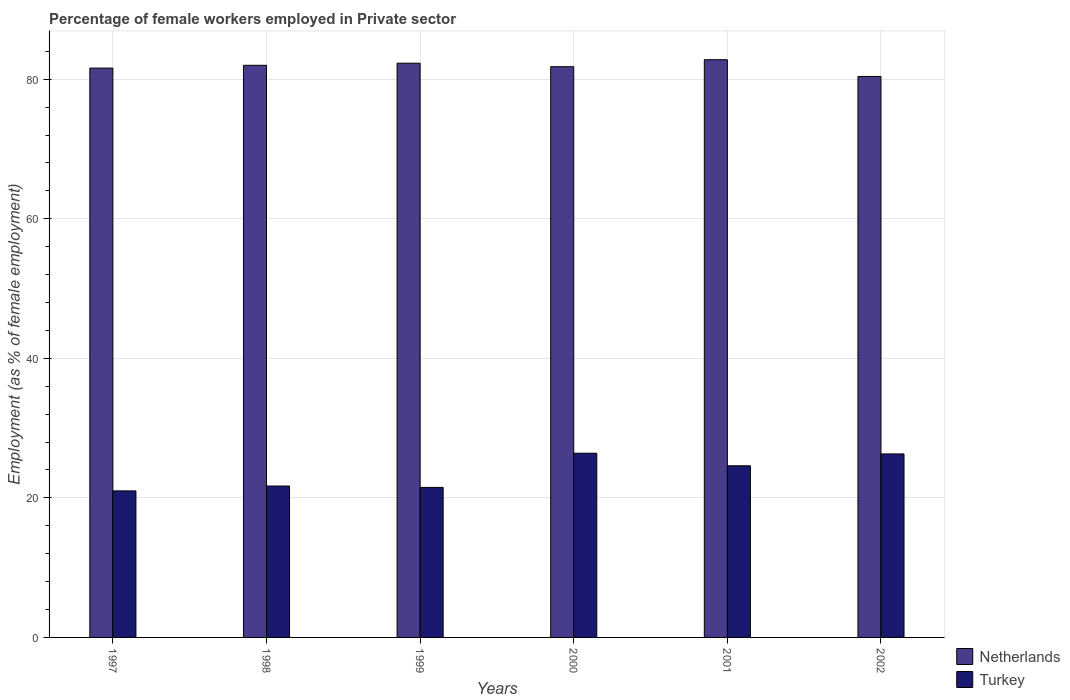Are the number of bars on each tick of the X-axis equal?
Keep it short and to the point. Yes. What is the label of the 3rd group of bars from the left?
Make the answer very short. 1999. Across all years, what is the maximum percentage of females employed in Private sector in Netherlands?
Give a very brief answer. 82.8. In which year was the percentage of females employed in Private sector in Netherlands maximum?
Provide a short and direct response. 2001. In which year was the percentage of females employed in Private sector in Netherlands minimum?
Your response must be concise. 2002. What is the total percentage of females employed in Private sector in Netherlands in the graph?
Keep it short and to the point. 490.9. What is the difference between the percentage of females employed in Private sector in Turkey in 1999 and that in 2000?
Provide a short and direct response. -4.9. What is the difference between the percentage of females employed in Private sector in Netherlands in 2002 and the percentage of females employed in Private sector in Turkey in 1999?
Ensure brevity in your answer.  58.9. What is the average percentage of females employed in Private sector in Netherlands per year?
Give a very brief answer. 81.82. In the year 2002, what is the difference between the percentage of females employed in Private sector in Netherlands and percentage of females employed in Private sector in Turkey?
Ensure brevity in your answer.  54.1. In how many years, is the percentage of females employed in Private sector in Turkey greater than 8 %?
Provide a succinct answer. 6. What is the ratio of the percentage of females employed in Private sector in Netherlands in 1997 to that in 1998?
Your response must be concise. 1. Is the difference between the percentage of females employed in Private sector in Netherlands in 1997 and 2001 greater than the difference between the percentage of females employed in Private sector in Turkey in 1997 and 2001?
Your answer should be compact. Yes. What is the difference between the highest and the second highest percentage of females employed in Private sector in Netherlands?
Provide a succinct answer. 0.5. What is the difference between the highest and the lowest percentage of females employed in Private sector in Turkey?
Keep it short and to the point. 5.4. What does the 2nd bar from the right in 1999 represents?
Offer a terse response. Netherlands. Are all the bars in the graph horizontal?
Keep it short and to the point. No. What is the difference between two consecutive major ticks on the Y-axis?
Make the answer very short. 20. Are the values on the major ticks of Y-axis written in scientific E-notation?
Make the answer very short. No. Does the graph contain any zero values?
Offer a terse response. No. Does the graph contain grids?
Offer a very short reply. Yes. How many legend labels are there?
Make the answer very short. 2. What is the title of the graph?
Offer a terse response. Percentage of female workers employed in Private sector. Does "Burundi" appear as one of the legend labels in the graph?
Offer a terse response. No. What is the label or title of the X-axis?
Your answer should be compact. Years. What is the label or title of the Y-axis?
Give a very brief answer. Employment (as % of female employment). What is the Employment (as % of female employment) of Netherlands in 1997?
Give a very brief answer. 81.6. What is the Employment (as % of female employment) of Turkey in 1998?
Your response must be concise. 21.7. What is the Employment (as % of female employment) of Netherlands in 1999?
Provide a succinct answer. 82.3. What is the Employment (as % of female employment) of Turkey in 1999?
Give a very brief answer. 21.5. What is the Employment (as % of female employment) in Netherlands in 2000?
Give a very brief answer. 81.8. What is the Employment (as % of female employment) of Turkey in 2000?
Your answer should be very brief. 26.4. What is the Employment (as % of female employment) of Netherlands in 2001?
Your answer should be compact. 82.8. What is the Employment (as % of female employment) of Turkey in 2001?
Give a very brief answer. 24.6. What is the Employment (as % of female employment) of Netherlands in 2002?
Offer a very short reply. 80.4. What is the Employment (as % of female employment) in Turkey in 2002?
Provide a short and direct response. 26.3. Across all years, what is the maximum Employment (as % of female employment) of Netherlands?
Your answer should be very brief. 82.8. Across all years, what is the maximum Employment (as % of female employment) of Turkey?
Provide a succinct answer. 26.4. Across all years, what is the minimum Employment (as % of female employment) of Netherlands?
Offer a very short reply. 80.4. Across all years, what is the minimum Employment (as % of female employment) of Turkey?
Provide a succinct answer. 21. What is the total Employment (as % of female employment) in Netherlands in the graph?
Make the answer very short. 490.9. What is the total Employment (as % of female employment) of Turkey in the graph?
Your answer should be very brief. 141.5. What is the difference between the Employment (as % of female employment) in Netherlands in 1997 and that in 1998?
Ensure brevity in your answer.  -0.4. What is the difference between the Employment (as % of female employment) of Turkey in 1997 and that in 1999?
Give a very brief answer. -0.5. What is the difference between the Employment (as % of female employment) of Netherlands in 1997 and that in 2000?
Your answer should be compact. -0.2. What is the difference between the Employment (as % of female employment) of Netherlands in 1997 and that in 2001?
Your response must be concise. -1.2. What is the difference between the Employment (as % of female employment) in Netherlands in 1997 and that in 2002?
Ensure brevity in your answer.  1.2. What is the difference between the Employment (as % of female employment) of Turkey in 1997 and that in 2002?
Your answer should be very brief. -5.3. What is the difference between the Employment (as % of female employment) of Turkey in 1998 and that in 1999?
Your response must be concise. 0.2. What is the difference between the Employment (as % of female employment) in Netherlands in 1998 and that in 2000?
Your answer should be compact. 0.2. What is the difference between the Employment (as % of female employment) in Turkey in 1998 and that in 2000?
Keep it short and to the point. -4.7. What is the difference between the Employment (as % of female employment) in Netherlands in 1998 and that in 2002?
Give a very brief answer. 1.6. What is the difference between the Employment (as % of female employment) of Turkey in 1999 and that in 2000?
Your answer should be compact. -4.9. What is the difference between the Employment (as % of female employment) of Netherlands in 1999 and that in 2001?
Give a very brief answer. -0.5. What is the difference between the Employment (as % of female employment) of Turkey in 1999 and that in 2001?
Keep it short and to the point. -3.1. What is the difference between the Employment (as % of female employment) of Netherlands in 1999 and that in 2002?
Your response must be concise. 1.9. What is the difference between the Employment (as % of female employment) in Turkey in 1999 and that in 2002?
Give a very brief answer. -4.8. What is the difference between the Employment (as % of female employment) in Turkey in 2000 and that in 2001?
Offer a very short reply. 1.8. What is the difference between the Employment (as % of female employment) in Netherlands in 2000 and that in 2002?
Your response must be concise. 1.4. What is the difference between the Employment (as % of female employment) in Turkey in 2000 and that in 2002?
Provide a short and direct response. 0.1. What is the difference between the Employment (as % of female employment) in Netherlands in 2001 and that in 2002?
Your answer should be compact. 2.4. What is the difference between the Employment (as % of female employment) in Netherlands in 1997 and the Employment (as % of female employment) in Turkey in 1998?
Offer a very short reply. 59.9. What is the difference between the Employment (as % of female employment) in Netherlands in 1997 and the Employment (as % of female employment) in Turkey in 1999?
Your answer should be compact. 60.1. What is the difference between the Employment (as % of female employment) in Netherlands in 1997 and the Employment (as % of female employment) in Turkey in 2000?
Ensure brevity in your answer.  55.2. What is the difference between the Employment (as % of female employment) in Netherlands in 1997 and the Employment (as % of female employment) in Turkey in 2002?
Provide a succinct answer. 55.3. What is the difference between the Employment (as % of female employment) of Netherlands in 1998 and the Employment (as % of female employment) of Turkey in 1999?
Make the answer very short. 60.5. What is the difference between the Employment (as % of female employment) in Netherlands in 1998 and the Employment (as % of female employment) in Turkey in 2000?
Your answer should be very brief. 55.6. What is the difference between the Employment (as % of female employment) of Netherlands in 1998 and the Employment (as % of female employment) of Turkey in 2001?
Keep it short and to the point. 57.4. What is the difference between the Employment (as % of female employment) in Netherlands in 1998 and the Employment (as % of female employment) in Turkey in 2002?
Keep it short and to the point. 55.7. What is the difference between the Employment (as % of female employment) of Netherlands in 1999 and the Employment (as % of female employment) of Turkey in 2000?
Provide a short and direct response. 55.9. What is the difference between the Employment (as % of female employment) of Netherlands in 1999 and the Employment (as % of female employment) of Turkey in 2001?
Your answer should be compact. 57.7. What is the difference between the Employment (as % of female employment) in Netherlands in 2000 and the Employment (as % of female employment) in Turkey in 2001?
Offer a terse response. 57.2. What is the difference between the Employment (as % of female employment) in Netherlands in 2000 and the Employment (as % of female employment) in Turkey in 2002?
Keep it short and to the point. 55.5. What is the difference between the Employment (as % of female employment) of Netherlands in 2001 and the Employment (as % of female employment) of Turkey in 2002?
Provide a succinct answer. 56.5. What is the average Employment (as % of female employment) of Netherlands per year?
Your response must be concise. 81.82. What is the average Employment (as % of female employment) in Turkey per year?
Keep it short and to the point. 23.58. In the year 1997, what is the difference between the Employment (as % of female employment) in Netherlands and Employment (as % of female employment) in Turkey?
Your answer should be very brief. 60.6. In the year 1998, what is the difference between the Employment (as % of female employment) of Netherlands and Employment (as % of female employment) of Turkey?
Give a very brief answer. 60.3. In the year 1999, what is the difference between the Employment (as % of female employment) of Netherlands and Employment (as % of female employment) of Turkey?
Your answer should be compact. 60.8. In the year 2000, what is the difference between the Employment (as % of female employment) of Netherlands and Employment (as % of female employment) of Turkey?
Keep it short and to the point. 55.4. In the year 2001, what is the difference between the Employment (as % of female employment) of Netherlands and Employment (as % of female employment) of Turkey?
Give a very brief answer. 58.2. In the year 2002, what is the difference between the Employment (as % of female employment) in Netherlands and Employment (as % of female employment) in Turkey?
Your answer should be very brief. 54.1. What is the ratio of the Employment (as % of female employment) in Turkey in 1997 to that in 1999?
Offer a terse response. 0.98. What is the ratio of the Employment (as % of female employment) of Netherlands in 1997 to that in 2000?
Your answer should be compact. 1. What is the ratio of the Employment (as % of female employment) in Turkey in 1997 to that in 2000?
Provide a short and direct response. 0.8. What is the ratio of the Employment (as % of female employment) of Netherlands in 1997 to that in 2001?
Provide a succinct answer. 0.99. What is the ratio of the Employment (as % of female employment) in Turkey in 1997 to that in 2001?
Provide a succinct answer. 0.85. What is the ratio of the Employment (as % of female employment) in Netherlands in 1997 to that in 2002?
Give a very brief answer. 1.01. What is the ratio of the Employment (as % of female employment) of Turkey in 1997 to that in 2002?
Offer a very short reply. 0.8. What is the ratio of the Employment (as % of female employment) of Turkey in 1998 to that in 1999?
Give a very brief answer. 1.01. What is the ratio of the Employment (as % of female employment) in Turkey in 1998 to that in 2000?
Offer a terse response. 0.82. What is the ratio of the Employment (as % of female employment) in Netherlands in 1998 to that in 2001?
Offer a terse response. 0.99. What is the ratio of the Employment (as % of female employment) of Turkey in 1998 to that in 2001?
Give a very brief answer. 0.88. What is the ratio of the Employment (as % of female employment) of Netherlands in 1998 to that in 2002?
Ensure brevity in your answer.  1.02. What is the ratio of the Employment (as % of female employment) in Turkey in 1998 to that in 2002?
Provide a short and direct response. 0.83. What is the ratio of the Employment (as % of female employment) in Turkey in 1999 to that in 2000?
Your answer should be very brief. 0.81. What is the ratio of the Employment (as % of female employment) of Netherlands in 1999 to that in 2001?
Provide a short and direct response. 0.99. What is the ratio of the Employment (as % of female employment) of Turkey in 1999 to that in 2001?
Offer a terse response. 0.87. What is the ratio of the Employment (as % of female employment) of Netherlands in 1999 to that in 2002?
Your answer should be very brief. 1.02. What is the ratio of the Employment (as % of female employment) of Turkey in 1999 to that in 2002?
Make the answer very short. 0.82. What is the ratio of the Employment (as % of female employment) in Netherlands in 2000 to that in 2001?
Keep it short and to the point. 0.99. What is the ratio of the Employment (as % of female employment) in Turkey in 2000 to that in 2001?
Offer a terse response. 1.07. What is the ratio of the Employment (as % of female employment) of Netherlands in 2000 to that in 2002?
Ensure brevity in your answer.  1.02. What is the ratio of the Employment (as % of female employment) in Turkey in 2000 to that in 2002?
Offer a very short reply. 1. What is the ratio of the Employment (as % of female employment) in Netherlands in 2001 to that in 2002?
Your response must be concise. 1.03. What is the ratio of the Employment (as % of female employment) in Turkey in 2001 to that in 2002?
Make the answer very short. 0.94. What is the difference between the highest and the second highest Employment (as % of female employment) of Turkey?
Provide a succinct answer. 0.1. What is the difference between the highest and the lowest Employment (as % of female employment) of Turkey?
Your answer should be compact. 5.4. 